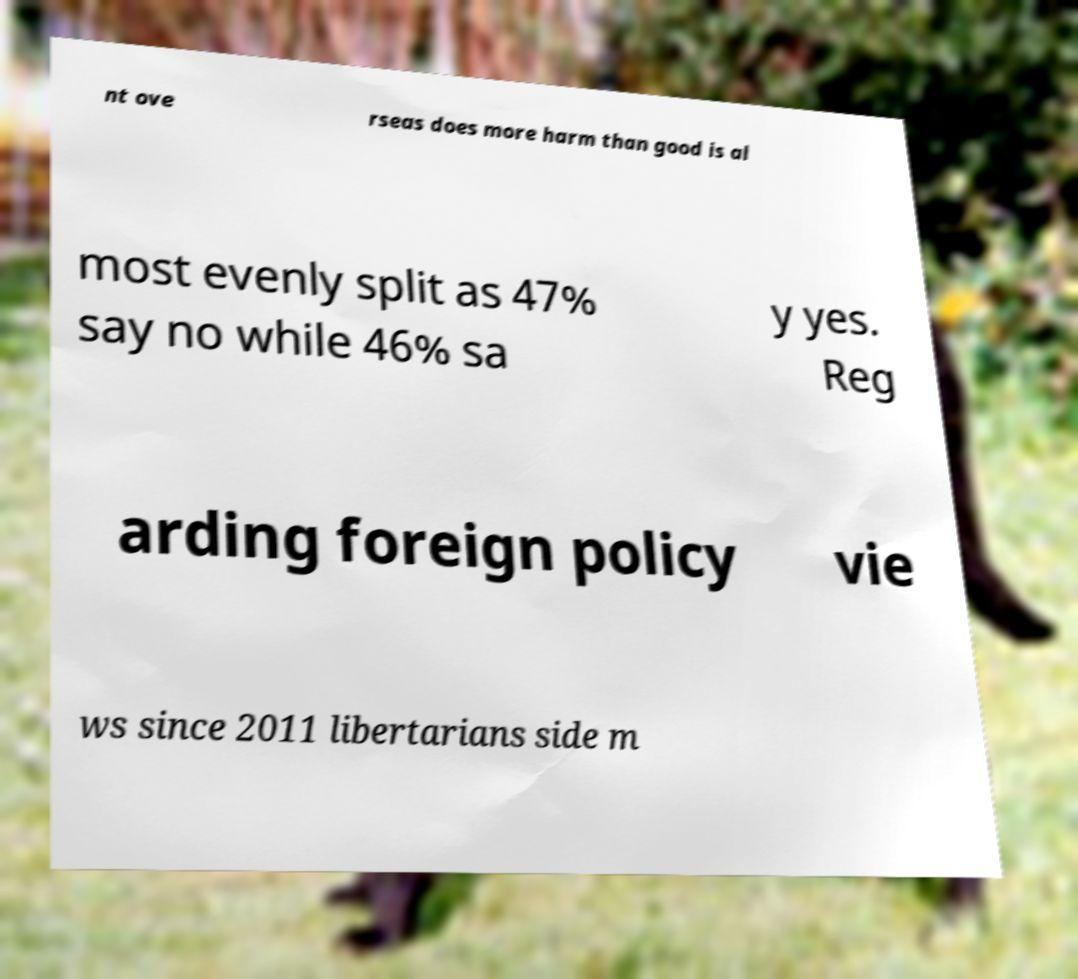Please identify and transcribe the text found in this image. nt ove rseas does more harm than good is al most evenly split as 47% say no while 46% sa y yes. Reg arding foreign policy vie ws since 2011 libertarians side m 